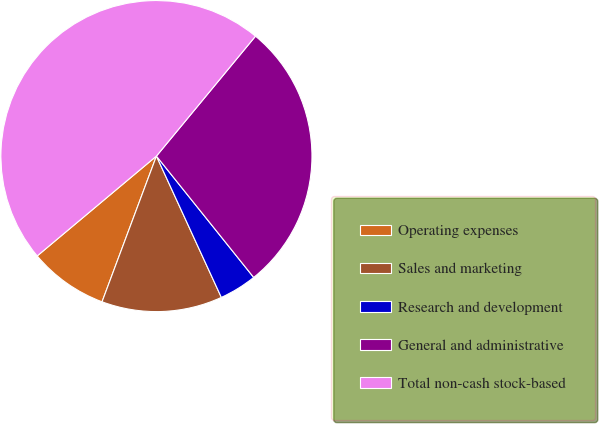<chart> <loc_0><loc_0><loc_500><loc_500><pie_chart><fcel>Operating expenses<fcel>Sales and marketing<fcel>Research and development<fcel>General and administrative<fcel>Total non-cash stock-based<nl><fcel>8.22%<fcel>12.54%<fcel>3.9%<fcel>28.26%<fcel>47.09%<nl></chart> 